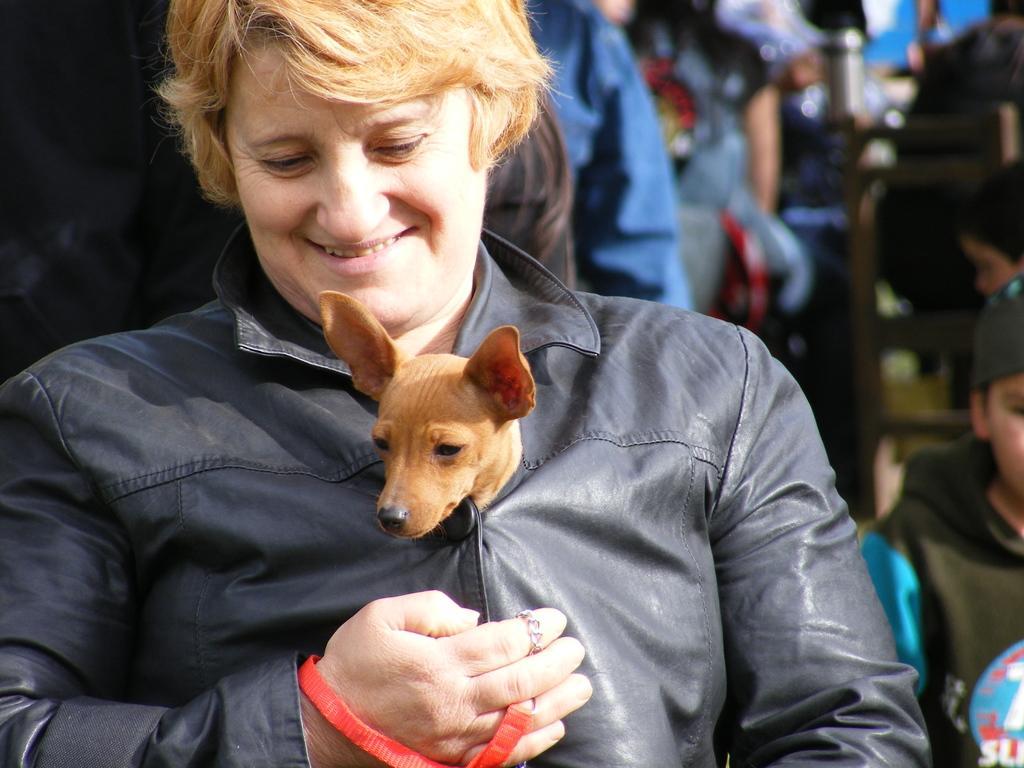In one or two sentences, can you explain what this image depicts? In this image I see a woman who is smiling and there is a dog in her clothes, In the background I see few people. 